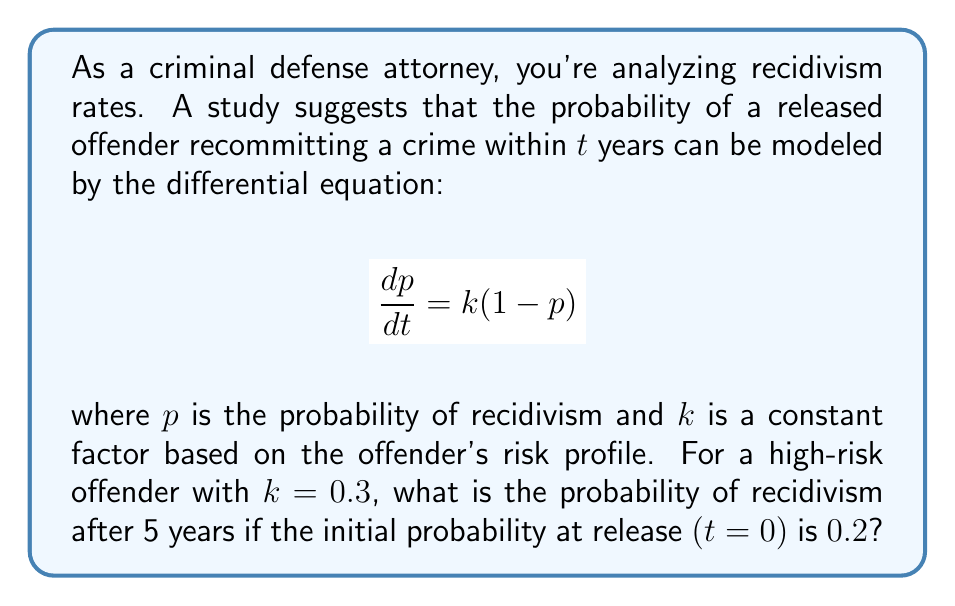Could you help me with this problem? 1) We start with the given differential equation:

   $$\frac{dp}{dt} = k(1-p)$$

2) Separate variables:

   $$\frac{dp}{1-p} = k dt$$

3) Integrate both sides:

   $$\int \frac{dp}{1-p} = \int k dt$$

4) Solve the integral:

   $$-\ln|1-p| = kt + C$$

5) Apply the initial condition: At t=0, p=0.2
   
   $$-\ln|1-0.2| = k(0) + C$$
   $$-\ln(0.8) = C$$

6) Substitute back into the general solution:

   $$-\ln|1-p| = kt - \ln(0.8)$$

7) Simplify:

   $$\ln|1-p| = \ln(0.8) - kt$$

8) Take exponential of both sides:

   $$1-p = 0.8e^{-kt}$$

9) Solve for p:

   $$p = 1 - 0.8e^{-kt}$$

10) Now, substitute k=0.3 and t=5:

    $$p = 1 - 0.8e^{-0.3(5)}$$
    $$p = 1 - 0.8e^{-1.5}$$
    $$p \approx 0.6411$$

Thus, the probability of recidivism after 5 years is approximately 0.6411 or 64.11%.
Answer: $0.6411$ or $64.11\%$ 